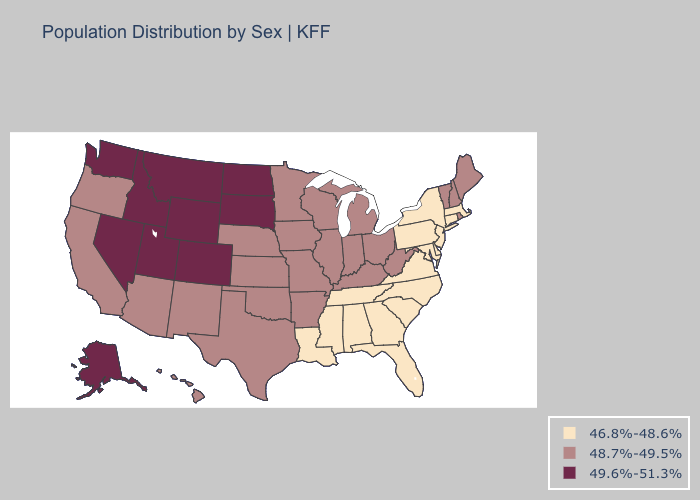Does the map have missing data?
Short answer required. No. Does New Mexico have the lowest value in the West?
Answer briefly. Yes. What is the lowest value in states that border Michigan?
Answer briefly. 48.7%-49.5%. Name the states that have a value in the range 46.8%-48.6%?
Quick response, please. Alabama, Connecticut, Delaware, Florida, Georgia, Louisiana, Maryland, Massachusetts, Mississippi, New Jersey, New York, North Carolina, Pennsylvania, South Carolina, Tennessee, Virginia. What is the value of Maryland?
Short answer required. 46.8%-48.6%. Which states hav the highest value in the Northeast?
Quick response, please. Maine, New Hampshire, Rhode Island, Vermont. What is the value of Rhode Island?
Short answer required. 48.7%-49.5%. Name the states that have a value in the range 46.8%-48.6%?
Answer briefly. Alabama, Connecticut, Delaware, Florida, Georgia, Louisiana, Maryland, Massachusetts, Mississippi, New Jersey, New York, North Carolina, Pennsylvania, South Carolina, Tennessee, Virginia. Does Iowa have the lowest value in the USA?
Write a very short answer. No. Which states have the lowest value in the USA?
Write a very short answer. Alabama, Connecticut, Delaware, Florida, Georgia, Louisiana, Maryland, Massachusetts, Mississippi, New Jersey, New York, North Carolina, Pennsylvania, South Carolina, Tennessee, Virginia. Does the first symbol in the legend represent the smallest category?
Concise answer only. Yes. How many symbols are there in the legend?
Be succinct. 3. Name the states that have a value in the range 48.7%-49.5%?
Keep it brief. Arizona, Arkansas, California, Hawaii, Illinois, Indiana, Iowa, Kansas, Kentucky, Maine, Michigan, Minnesota, Missouri, Nebraska, New Hampshire, New Mexico, Ohio, Oklahoma, Oregon, Rhode Island, Texas, Vermont, West Virginia, Wisconsin. What is the lowest value in the West?
Quick response, please. 48.7%-49.5%. Which states have the highest value in the USA?
Short answer required. Alaska, Colorado, Idaho, Montana, Nevada, North Dakota, South Dakota, Utah, Washington, Wyoming. 